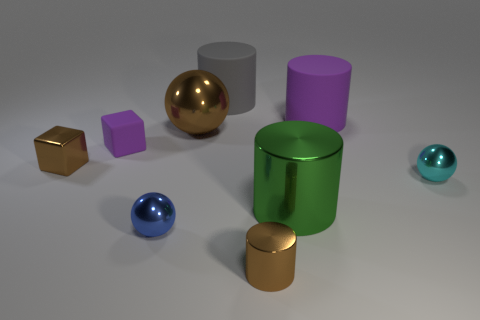Add 1 large gray rubber cylinders. How many objects exist? 10 Subtract all green cylinders. How many cylinders are left? 3 Subtract 1 cubes. How many cubes are left? 1 Subtract all blue balls. How many balls are left? 2 Subtract 1 cyan balls. How many objects are left? 8 Subtract all cylinders. How many objects are left? 5 Subtract all blue cylinders. Subtract all green spheres. How many cylinders are left? 4 Subtract all gray cubes. How many brown cylinders are left? 1 Subtract all large rubber cylinders. Subtract all small matte objects. How many objects are left? 6 Add 3 large gray matte objects. How many large gray matte objects are left? 4 